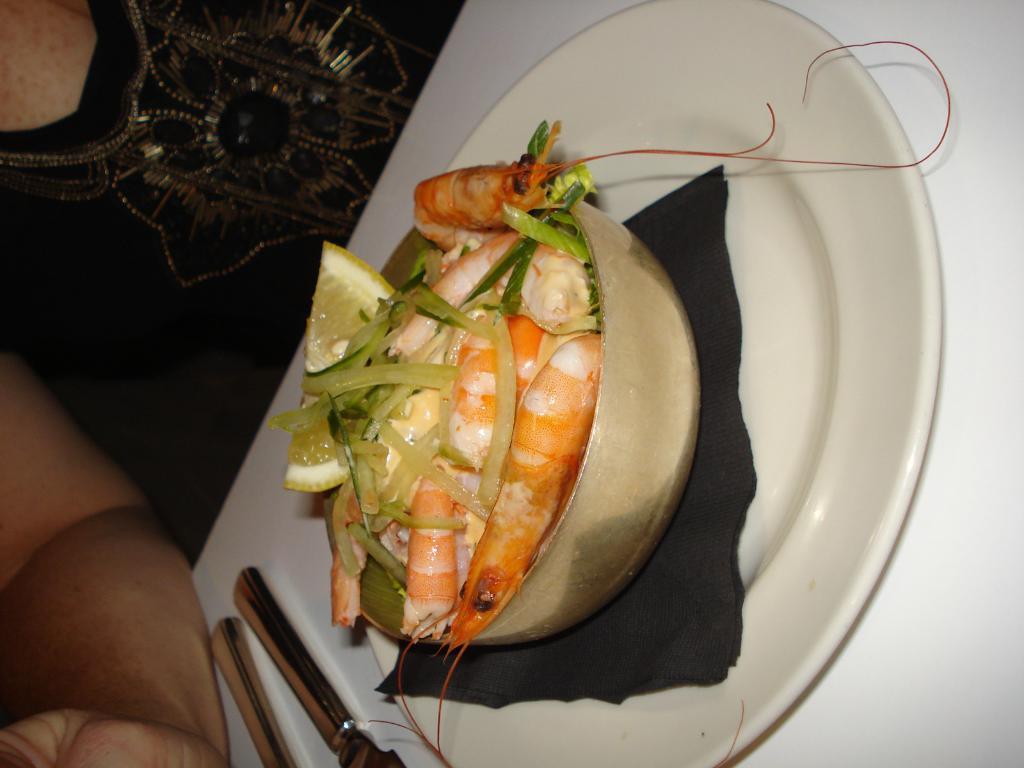Can you describe this image briefly? In this picture I can see a human and I can see food with couple of lemon pieces in the bowl on the plate and I can see a knife on the table. 